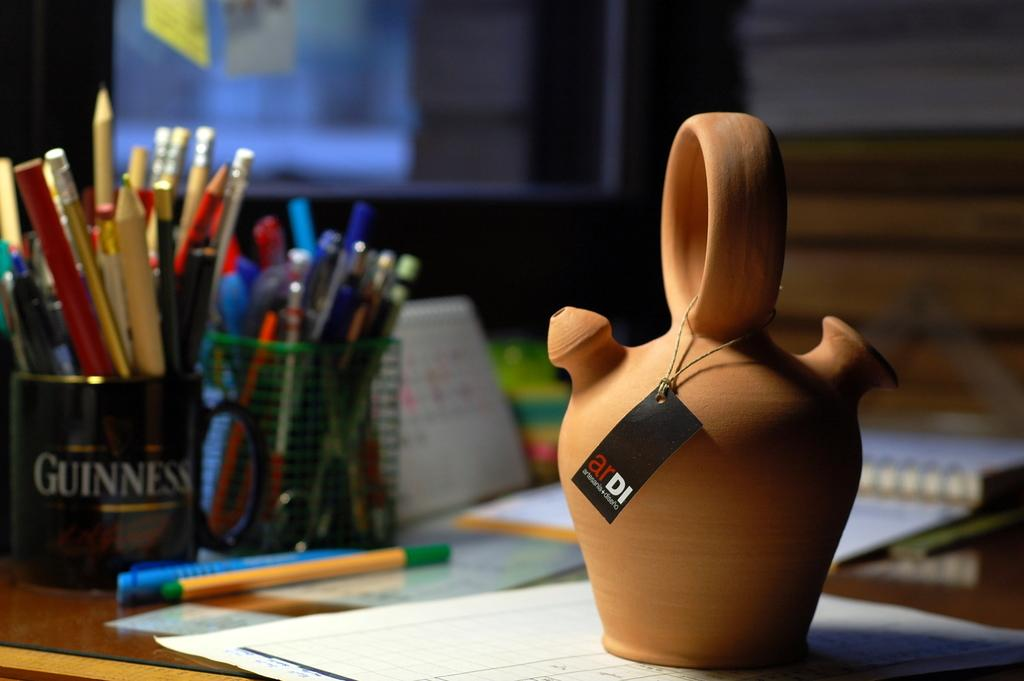<image>
Provide a brief description of the given image. A desk with a coffee cup that says Guinness full of writing utensils 